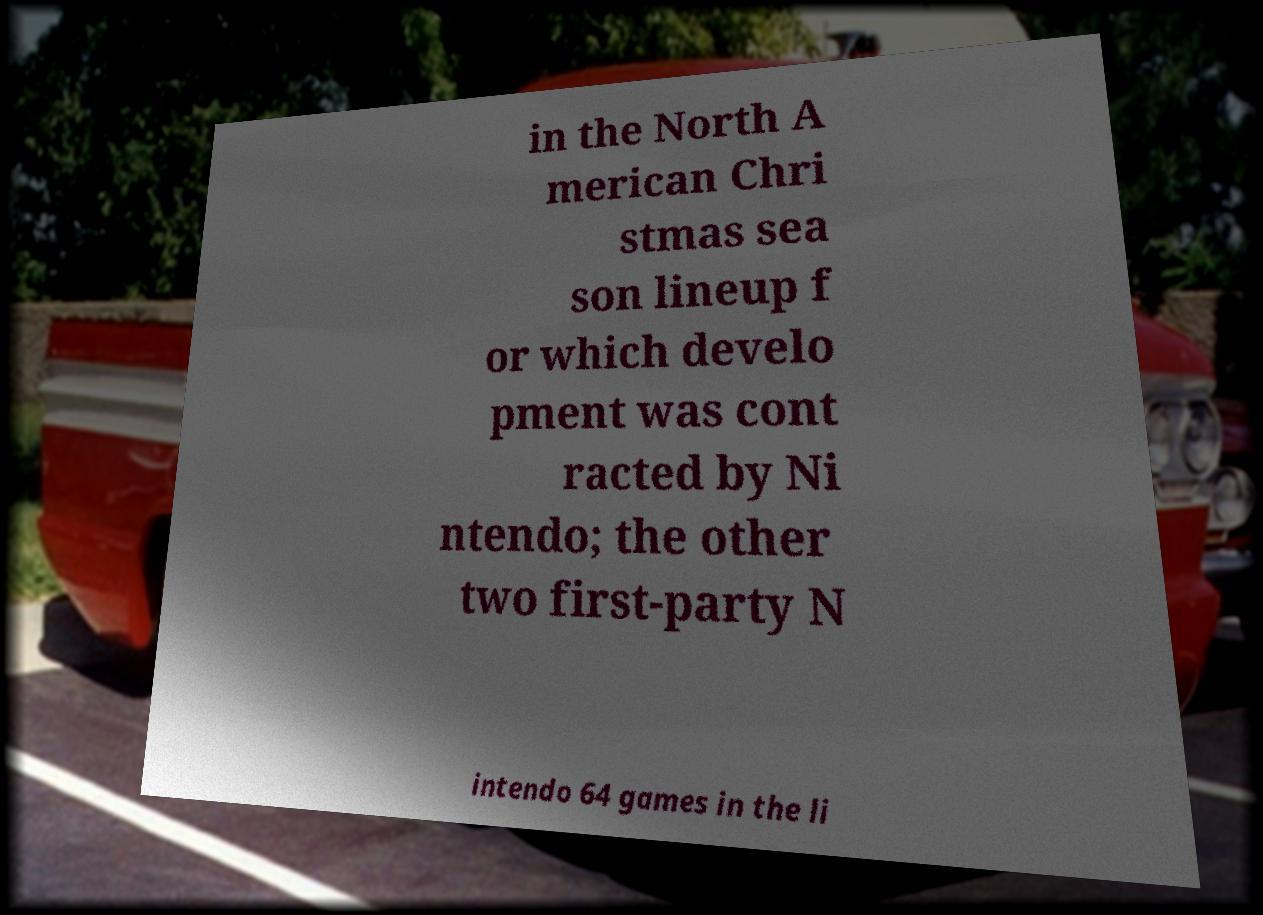Please identify and transcribe the text found in this image. in the North A merican Chri stmas sea son lineup f or which develo pment was cont racted by Ni ntendo; the other two first-party N intendo 64 games in the li 